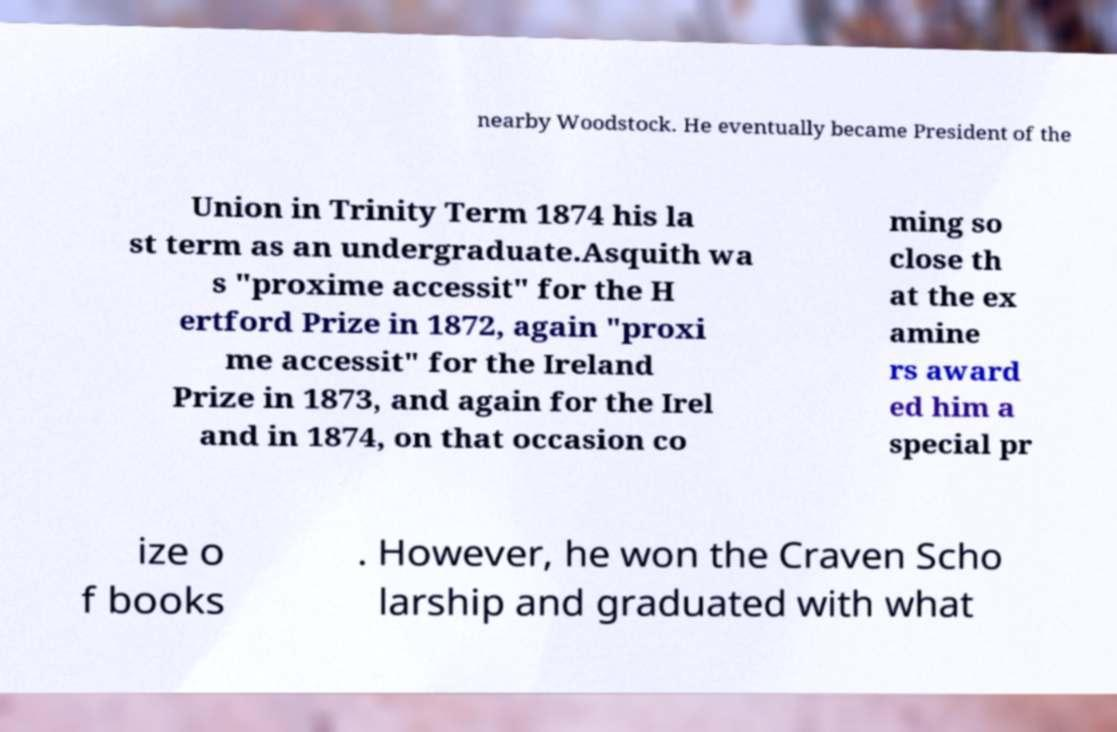For documentation purposes, I need the text within this image transcribed. Could you provide that? nearby Woodstock. He eventually became President of the Union in Trinity Term 1874 his la st term as an undergraduate.Asquith wa s "proxime accessit" for the H ertford Prize in 1872, again "proxi me accessit" for the Ireland Prize in 1873, and again for the Irel and in 1874, on that occasion co ming so close th at the ex amine rs award ed him a special pr ize o f books . However, he won the Craven Scho larship and graduated with what 